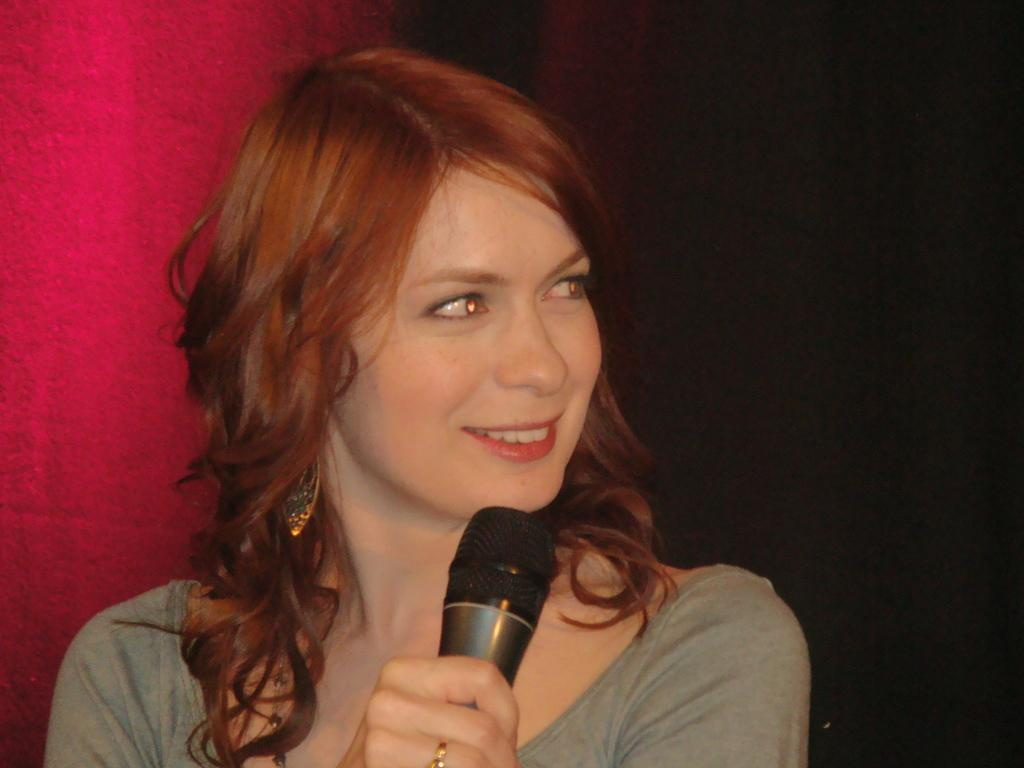Who is the main subject in the image? There is a lady in the image. Can you describe the lady's appearance? The lady has short hair. What is the lady holding in her right hand? The lady is holding a mic in her right hand. What color is the wall in the background? There is a red color wall in the background. What type of canvas is the lady painting in the image? There is no canvas present in the image, and the lady is not shown painting. 